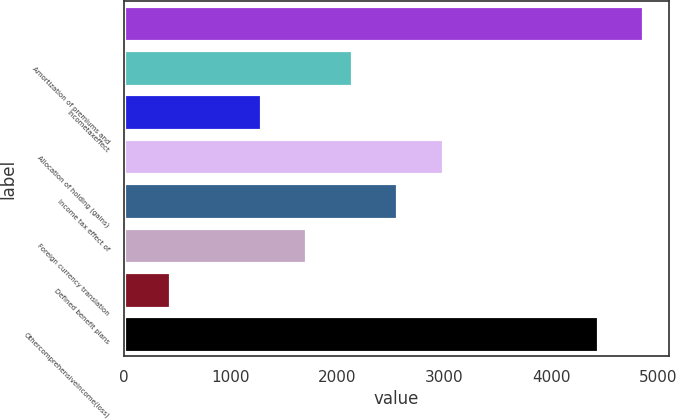<chart> <loc_0><loc_0><loc_500><loc_500><bar_chart><ecel><fcel>Amortization of premiums and<fcel>Incometaxeffect<fcel>Allocation of holding (gains)<fcel>Income tax effect of<fcel>Foreign currency translation<fcel>Defined benefit plans<fcel>Othercomprehensiveincome(loss)<nl><fcel>4858<fcel>2135<fcel>1283<fcel>2987<fcel>2561<fcel>1709<fcel>431<fcel>4432<nl></chart> 